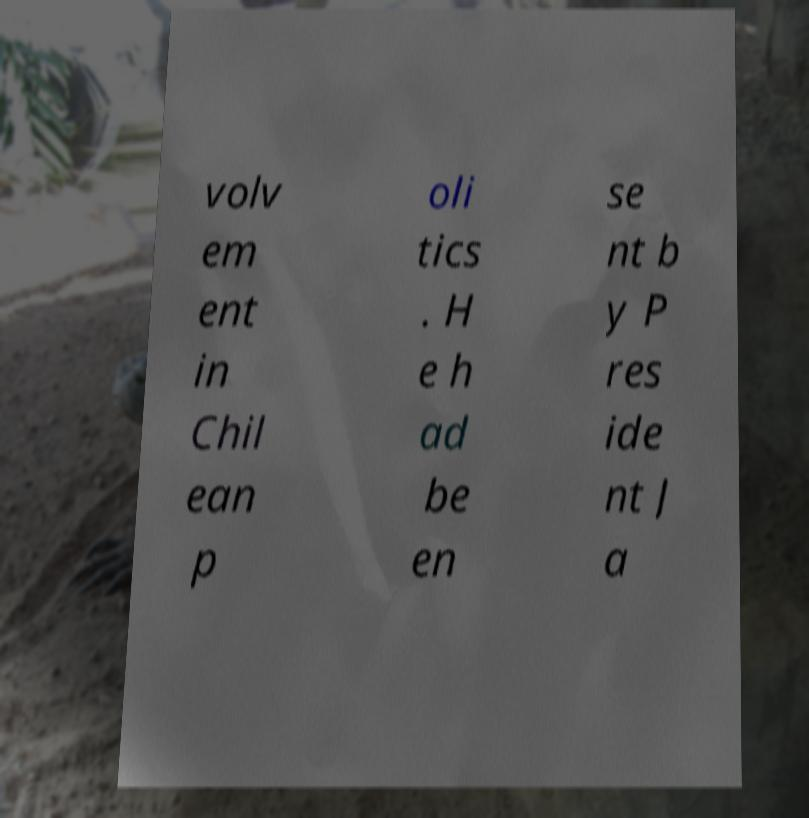Could you assist in decoding the text presented in this image and type it out clearly? volv em ent in Chil ean p oli tics . H e h ad be en se nt b y P res ide nt J a 